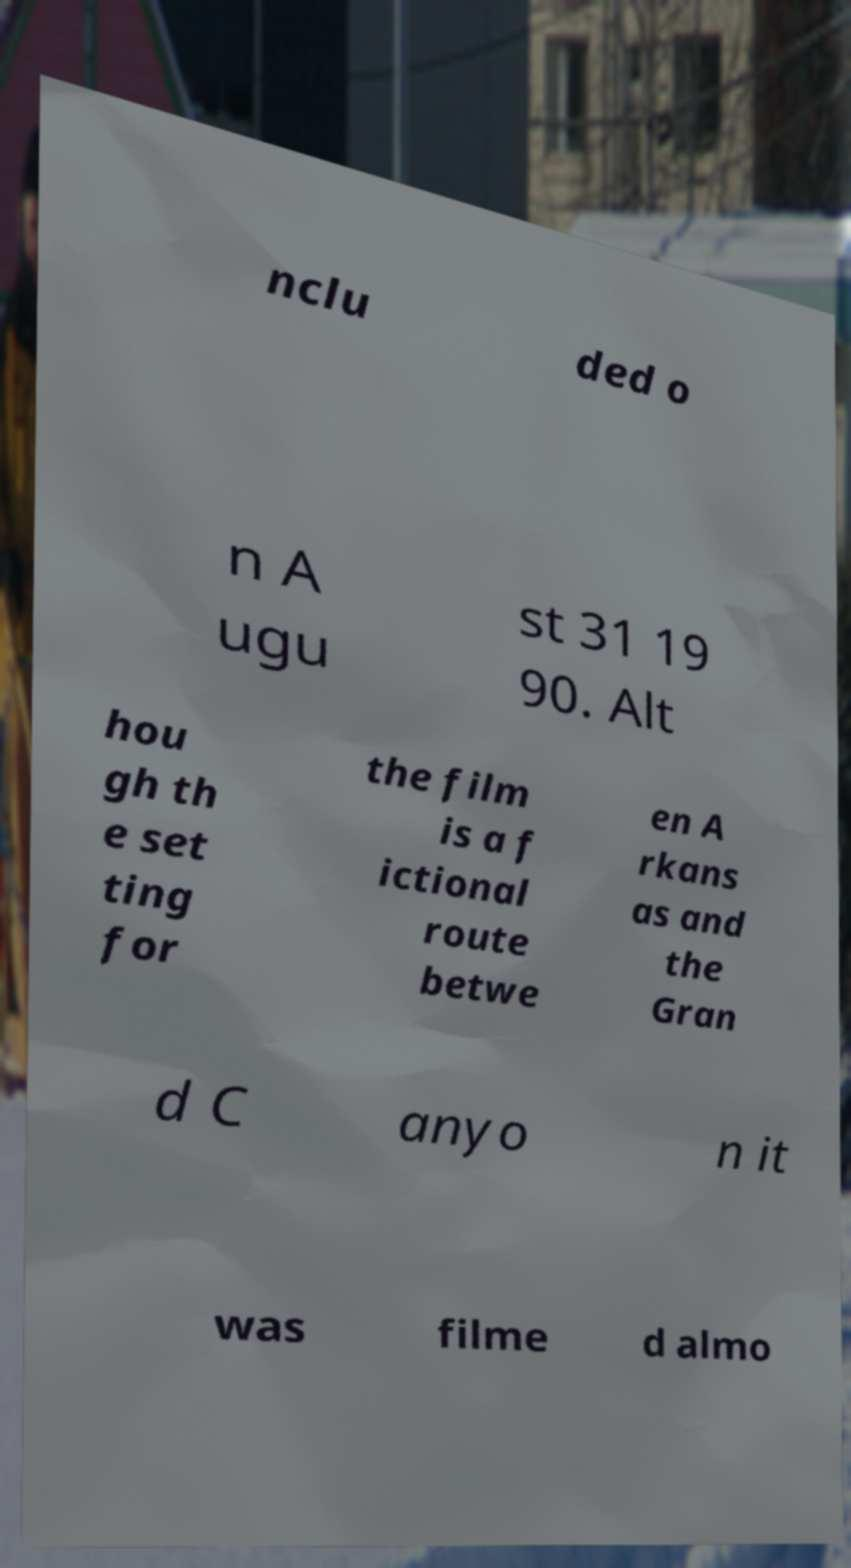Can you accurately transcribe the text from the provided image for me? nclu ded o n A ugu st 31 19 90. Alt hou gh th e set ting for the film is a f ictional route betwe en A rkans as and the Gran d C anyo n it was filme d almo 